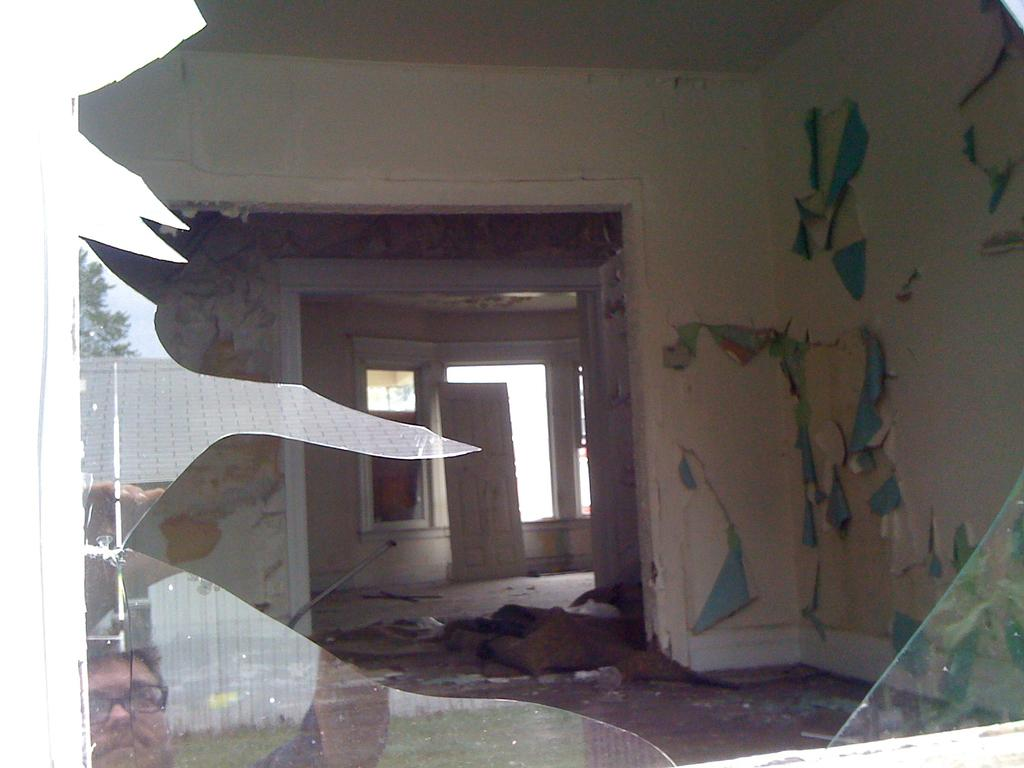What is present on the ground in the image? There is broken window glass in the image. What can be seen in the reflection on the glass? The reflection of a man is visible on the glass. What is the man wearing in the image? The man is wearing clothes and spectacles. What type of structure is present in the image? There is a wall and a window in the image. How many kittens are sitting on the man's lap in the image? There are no kittens present in the image. What achievement is the man celebrating in the image? The image does not provide any information about the man's achievements or any reason for celebration. 